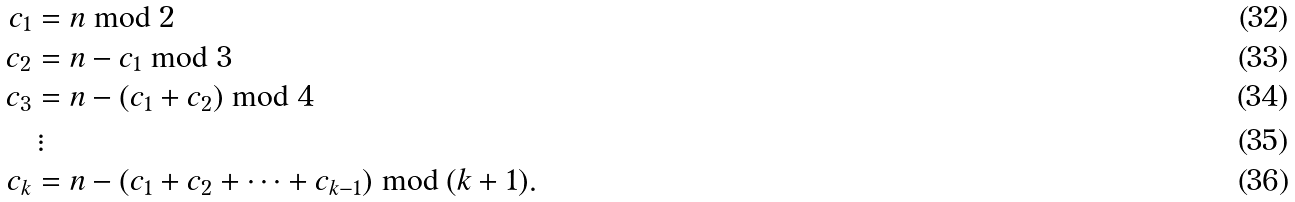<formula> <loc_0><loc_0><loc_500><loc_500>c _ { 1 } & = n \bmod 2 \\ c _ { 2 } & = n - c _ { 1 } \bmod 3 \\ c _ { 3 } & = n - ( c _ { 1 } + c _ { 2 } ) \bmod 4 \\ & \, \vdots \\ c _ { k } & = n - ( c _ { 1 } + c _ { 2 } + \cdots + c _ { k - 1 } ) \bmod ( k + 1 ) .</formula> 